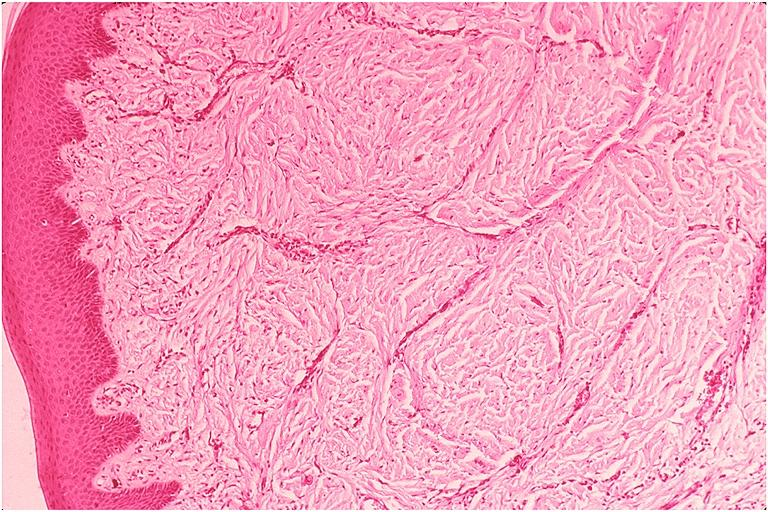s oral present?
Answer the question using a single word or phrase. Yes 